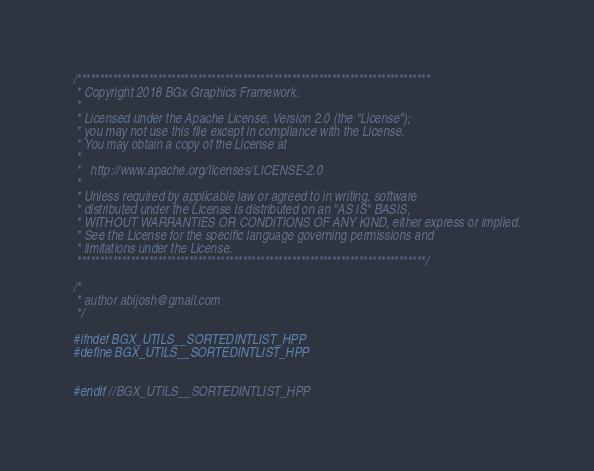<code> <loc_0><loc_0><loc_500><loc_500><_C++_>/*******************************************************************************
 * Copyright 2018 BGx Graphics Framework.
 * 
 * Licensed under the Apache License, Version 2.0 (the "License");
 * you may not use this file except in compliance with the License.
 * You may obtain a copy of the License at
 * 
 *   http://www.apache.org/licenses/LICENSE-2.0
 * 
 * Unless required by applicable law or agreed to in writing, software
 * distributed under the License is distributed on an "AS IS" BASIS,
 * WITHOUT WARRANTIES OR CONDITIONS OF ANY KIND, either express or implied.
 * See the License for the specific language governing permissions and
 * limitations under the License.
 ******************************************************************************/

/*
 * author abijosh@gmail.com
 */

#ifndef BGX_UTILS__SORTEDINTLIST_HPP
#define BGX_UTILS__SORTEDINTLIST_HPP


#endif //BGX_UTILS__SORTEDINTLIST_HPP</code> 